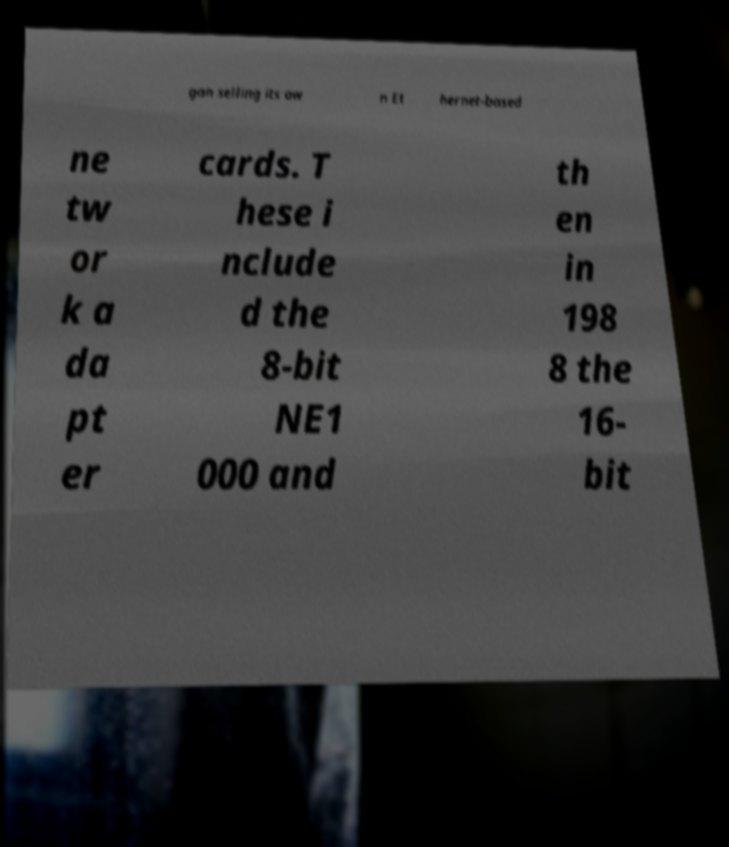There's text embedded in this image that I need extracted. Can you transcribe it verbatim? gan selling its ow n Et hernet-based ne tw or k a da pt er cards. T hese i nclude d the 8-bit NE1 000 and th en in 198 8 the 16- bit 